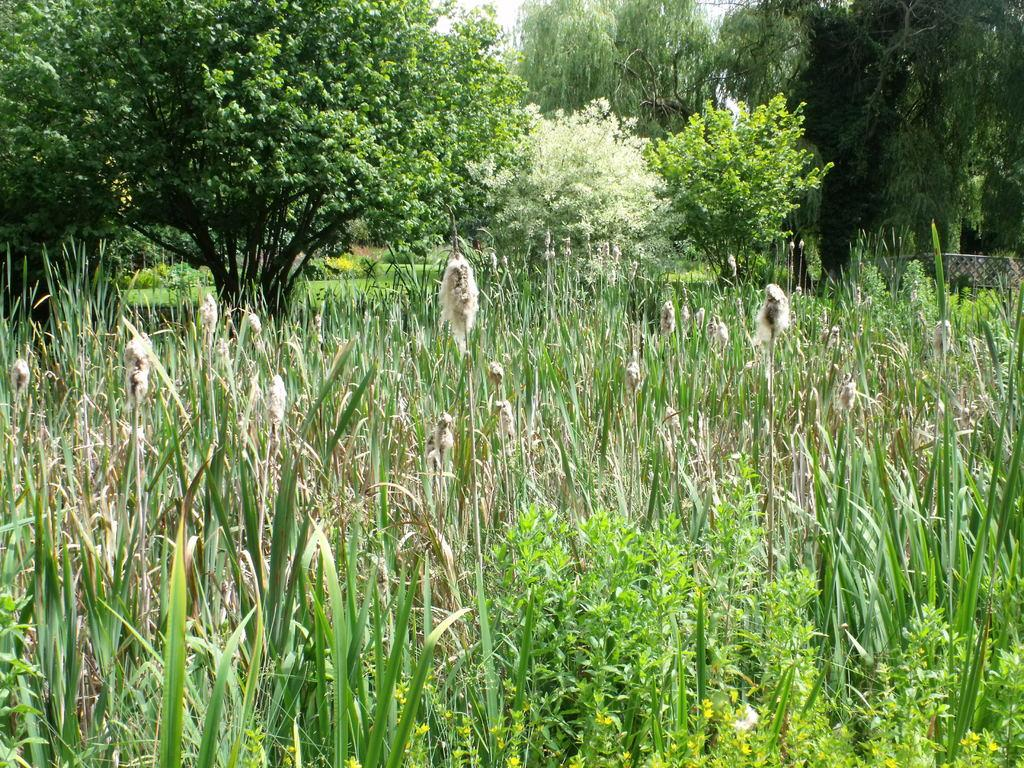What type of vegetation is present on the ground in the image? There are plants on the ground in the image. What can be seen in the background of the image? There are trees in the background of the image. How many attempts were made to unlock the waste bin in the image? There is no waste bin or lock present in the image. What type of waste is visible in the image? There is no waste present in the image; it features plants on the ground and trees in the background. 